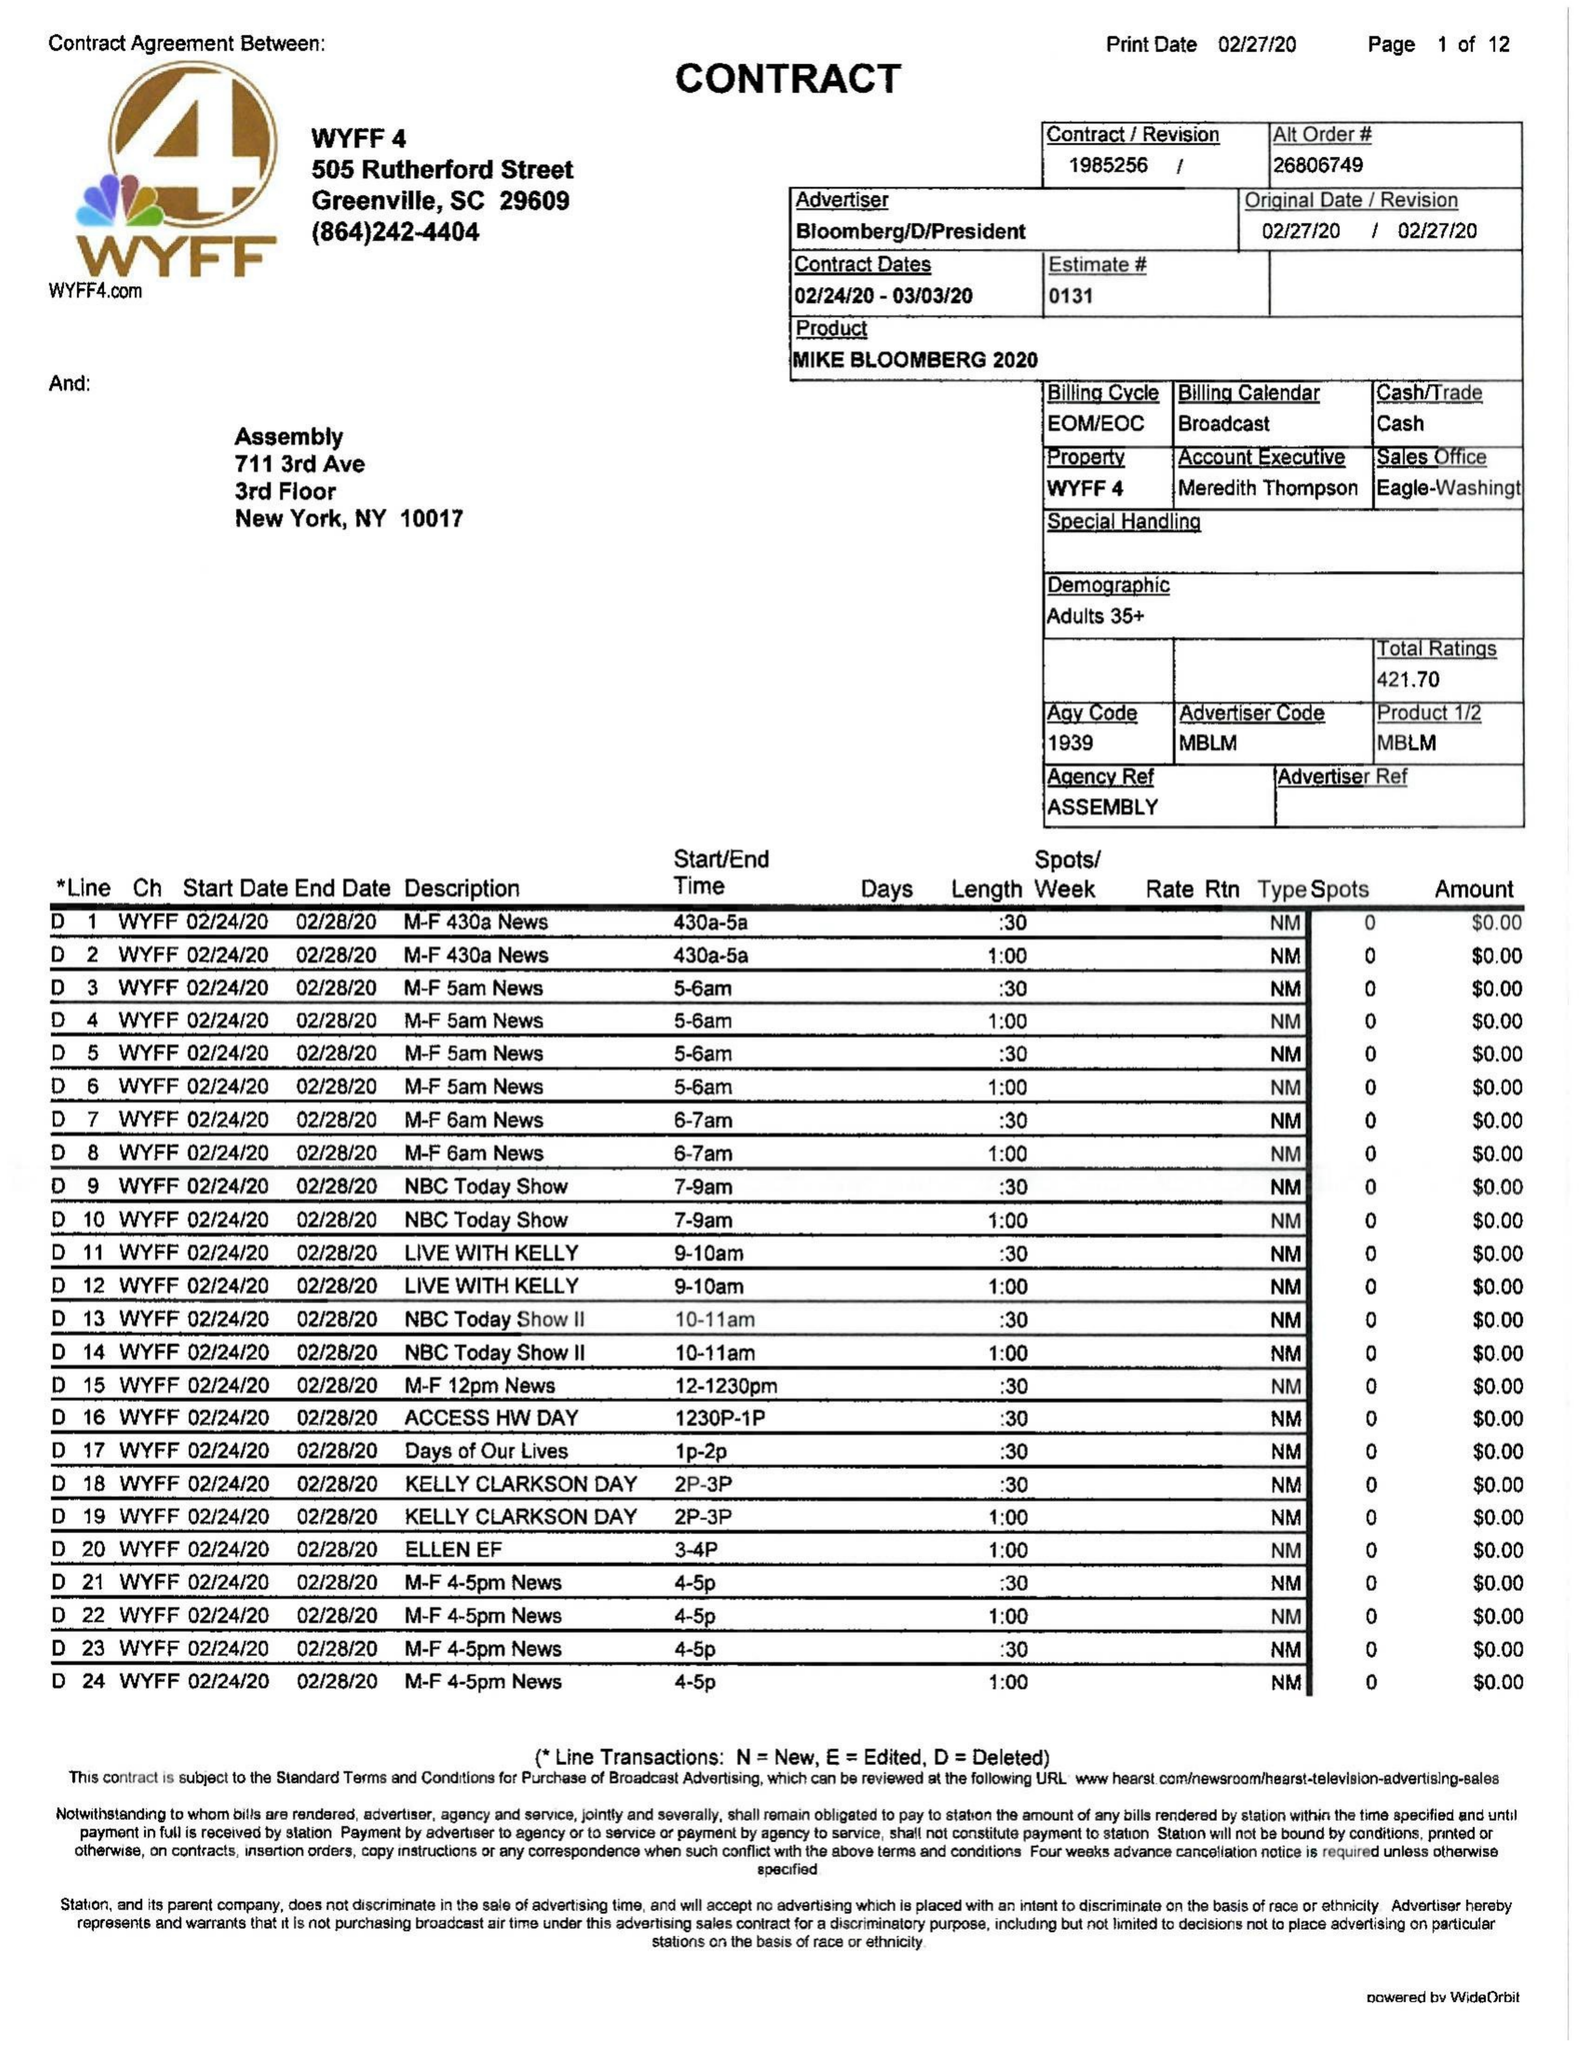What is the value for the gross_amount?
Answer the question using a single word or phrase. 56890.00 